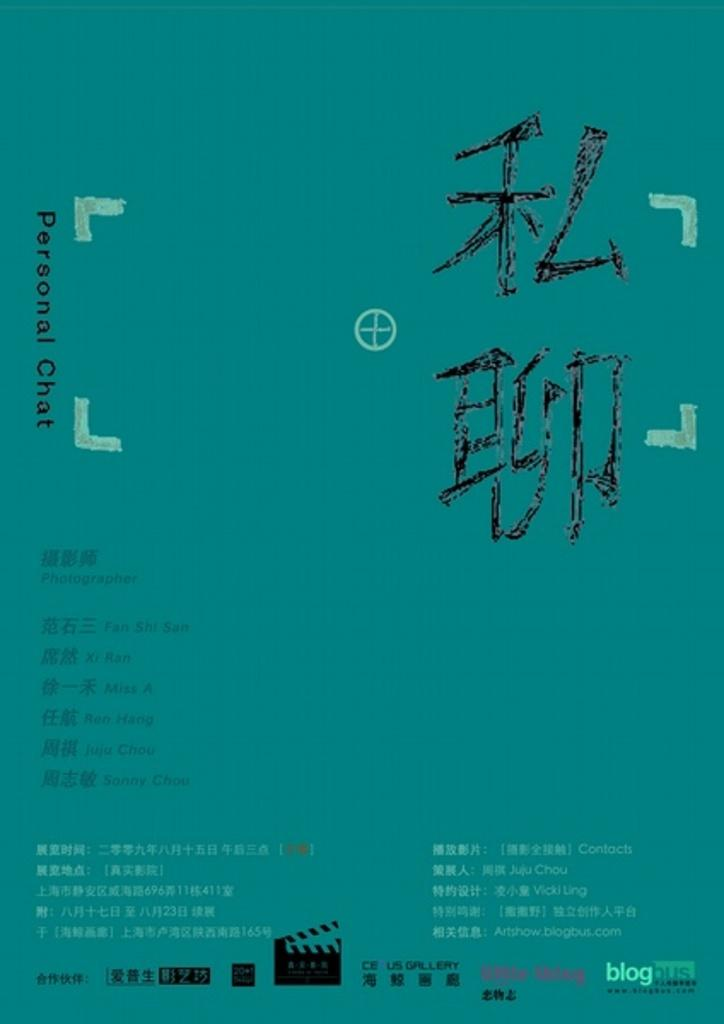<image>
Provide a brief description of the given image. A blogbus personal chat screen in a foreign language 